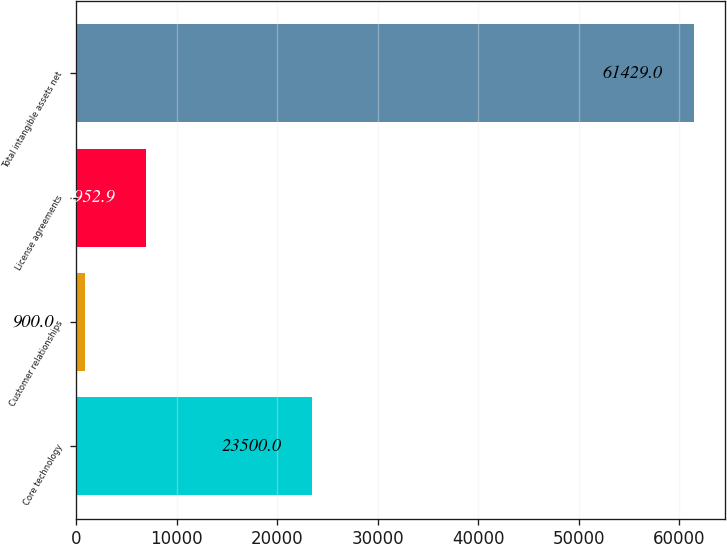<chart> <loc_0><loc_0><loc_500><loc_500><bar_chart><fcel>Core technology<fcel>Customer relationships<fcel>License agreements<fcel>Total intangible assets net<nl><fcel>23500<fcel>900<fcel>6952.9<fcel>61429<nl></chart> 